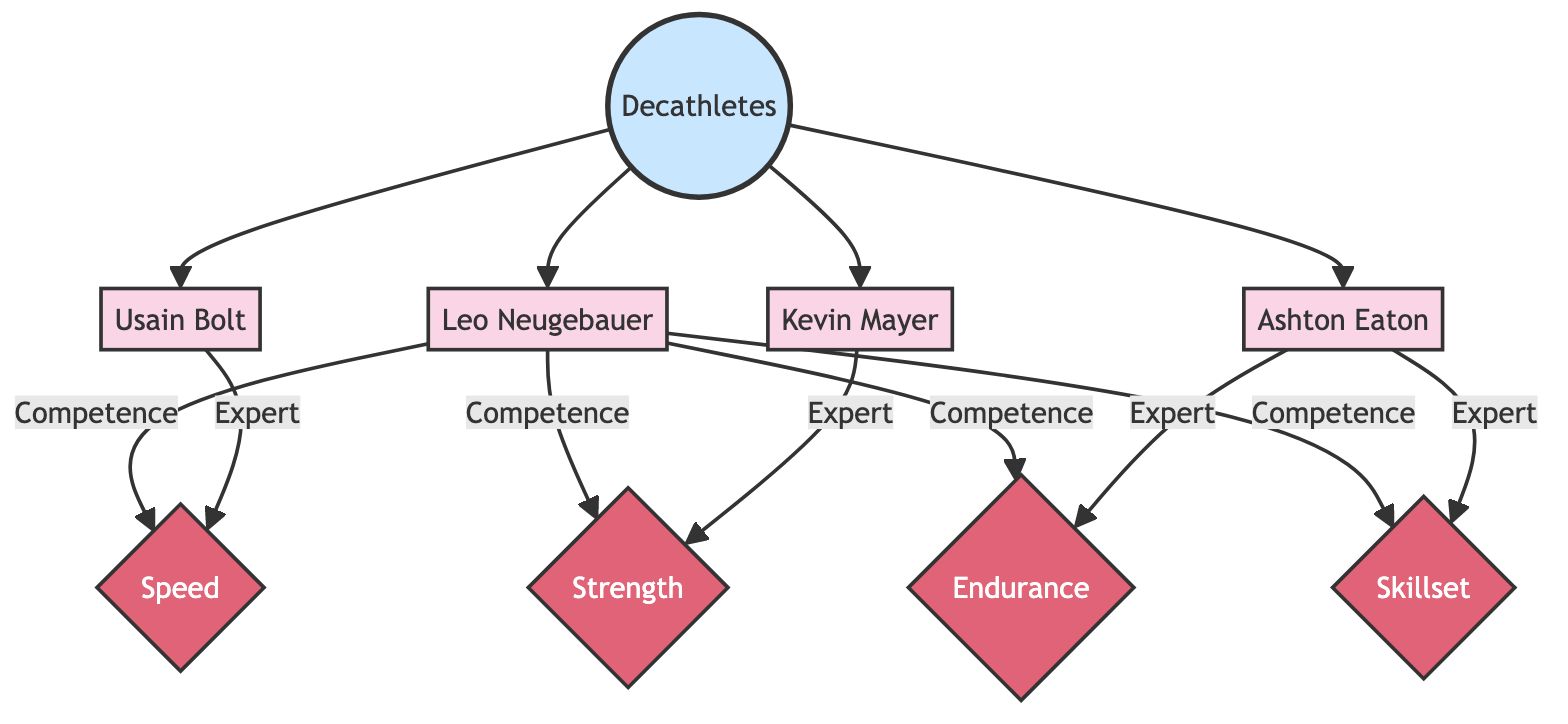What is the main category of the diagram? The main category depicted in the diagram is "Decathletes," which encompasses various athletes and their respective statistics. This is clear as "Decathletes" is the primary node that connects to all individual athletes.
Answer: Decathletes How many athletes are represented in the diagram? There are four athletes represented in the diagram: Leo Neugebauer, Usain Bolt, Kevin Mayer, and Ashton Eaton. Each athlete is a separate node connected to the central category.
Answer: Four Which athlete is highlighted as an expert in speed? Usain Bolt is highlighted as an expert in speed, indicated by the "Expert" designation connected to the Speed attribute in the diagram.
Answer: Usain Bolt What skills does Ashton Eaton specialize in according to the diagram? According to the diagram, Ashton Eaton specializes in both Endurance and Skillset, as he is marked as an expert in these two attributes.
Answer: Endurance, Skillset Does Leo Neugebauer have a direct connection to any of the performance attributes? Yes, Leo Neugebauer has direct connections to all four performance attributes: Speed, Strength, Endurance, and Skillset, indicating his diverse competencies.
Answer: Yes Which athlete shows the highest degree of competence in Strength? Kevin Mayer is shown as the expert in Strength, making him the athlete with the highest degree of competence in that specific attribute based on the diagram.
Answer: Kevin Mayer Who among the athletes has a competence link to endurance? Leo Neugebauer has a competence link to Endurance, showing that he is recognized for his abilities in that performance area.
Answer: Leo Neugebauer How does Leo Neugebauer's skillset compare to the other athletes? Leo Neugebauer's skillset is acknowledged as a competence in the diagram, but he is not identified as an expert like Ashton Eaton, showing a comparative level of skill.
Answer: Competence What is the relationship between decathletes and their performance attributes? The relationship is that each decathlete has competency links to multiple attributes, showing how they are evaluated in different performance areas within the sport.
Answer: Competency links 